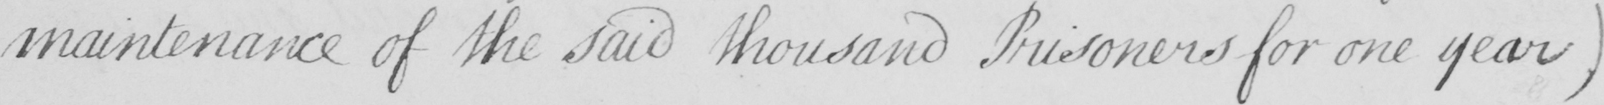Please transcribe the handwritten text in this image. maintenance of the said thousand Prisoners for one year ) 